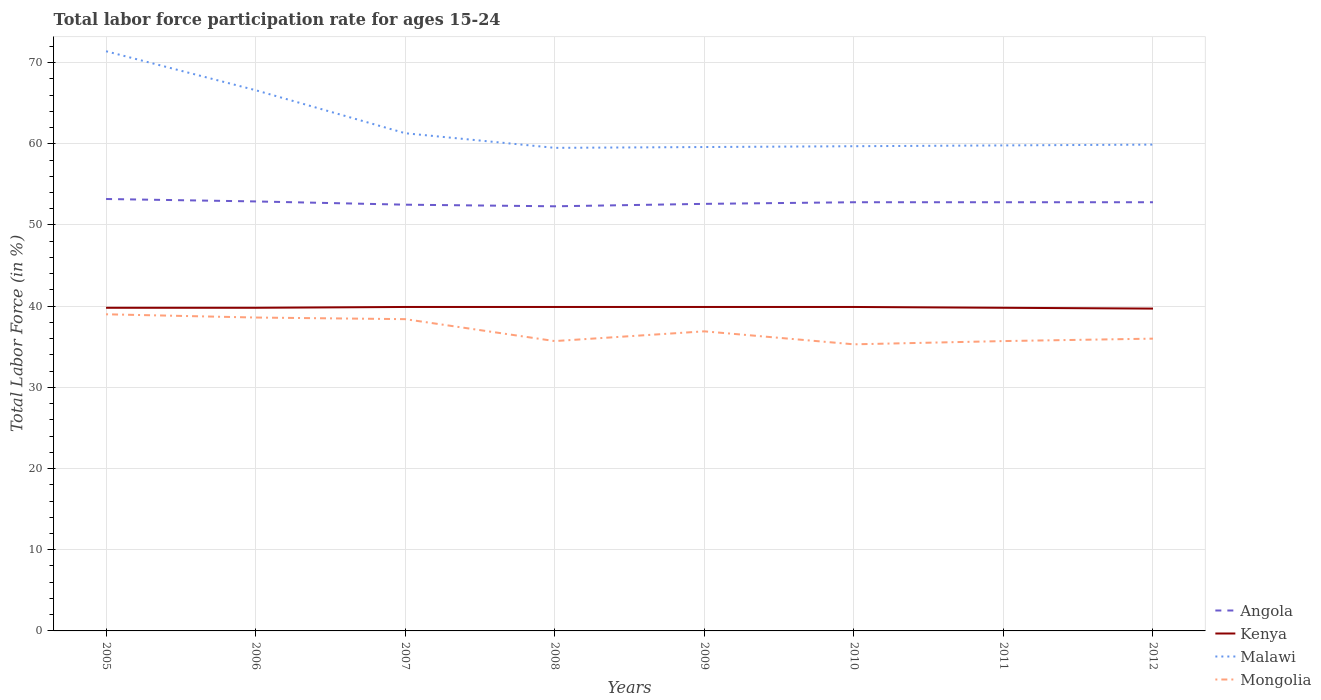Does the line corresponding to Mongolia intersect with the line corresponding to Angola?
Your answer should be compact. No. Across all years, what is the maximum labor force participation rate in Mongolia?
Make the answer very short. 35.3. In which year was the labor force participation rate in Mongolia maximum?
Offer a very short reply. 2010. What is the total labor force participation rate in Mongolia in the graph?
Keep it short and to the point. 0.4. What is the difference between the highest and the second highest labor force participation rate in Mongolia?
Give a very brief answer. 3.7. What is the difference between the highest and the lowest labor force participation rate in Malawi?
Your answer should be very brief. 2. Is the labor force participation rate in Kenya strictly greater than the labor force participation rate in Malawi over the years?
Your response must be concise. Yes. How many lines are there?
Provide a short and direct response. 4. How many years are there in the graph?
Provide a short and direct response. 8. Are the values on the major ticks of Y-axis written in scientific E-notation?
Provide a succinct answer. No. Does the graph contain any zero values?
Your response must be concise. No. How are the legend labels stacked?
Your answer should be very brief. Vertical. What is the title of the graph?
Offer a very short reply. Total labor force participation rate for ages 15-24. What is the label or title of the Y-axis?
Offer a very short reply. Total Labor Force (in %). What is the Total Labor Force (in %) of Angola in 2005?
Keep it short and to the point. 53.2. What is the Total Labor Force (in %) in Kenya in 2005?
Your answer should be compact. 39.8. What is the Total Labor Force (in %) of Malawi in 2005?
Your response must be concise. 71.4. What is the Total Labor Force (in %) of Angola in 2006?
Ensure brevity in your answer.  52.9. What is the Total Labor Force (in %) of Kenya in 2006?
Your answer should be very brief. 39.8. What is the Total Labor Force (in %) in Malawi in 2006?
Provide a succinct answer. 66.6. What is the Total Labor Force (in %) of Mongolia in 2006?
Ensure brevity in your answer.  38.6. What is the Total Labor Force (in %) in Angola in 2007?
Your response must be concise. 52.5. What is the Total Labor Force (in %) of Kenya in 2007?
Make the answer very short. 39.9. What is the Total Labor Force (in %) in Malawi in 2007?
Offer a very short reply. 61.3. What is the Total Labor Force (in %) in Mongolia in 2007?
Make the answer very short. 38.4. What is the Total Labor Force (in %) in Angola in 2008?
Your answer should be very brief. 52.3. What is the Total Labor Force (in %) in Kenya in 2008?
Your answer should be compact. 39.9. What is the Total Labor Force (in %) of Malawi in 2008?
Offer a very short reply. 59.5. What is the Total Labor Force (in %) of Mongolia in 2008?
Make the answer very short. 35.7. What is the Total Labor Force (in %) in Angola in 2009?
Provide a short and direct response. 52.6. What is the Total Labor Force (in %) of Kenya in 2009?
Give a very brief answer. 39.9. What is the Total Labor Force (in %) of Malawi in 2009?
Offer a very short reply. 59.6. What is the Total Labor Force (in %) in Mongolia in 2009?
Your response must be concise. 36.9. What is the Total Labor Force (in %) in Angola in 2010?
Offer a terse response. 52.8. What is the Total Labor Force (in %) of Kenya in 2010?
Offer a terse response. 39.9. What is the Total Labor Force (in %) of Malawi in 2010?
Provide a succinct answer. 59.7. What is the Total Labor Force (in %) of Mongolia in 2010?
Offer a very short reply. 35.3. What is the Total Labor Force (in %) in Angola in 2011?
Your answer should be very brief. 52.8. What is the Total Labor Force (in %) in Kenya in 2011?
Provide a short and direct response. 39.8. What is the Total Labor Force (in %) of Malawi in 2011?
Offer a very short reply. 59.8. What is the Total Labor Force (in %) in Mongolia in 2011?
Your answer should be very brief. 35.7. What is the Total Labor Force (in %) of Angola in 2012?
Provide a succinct answer. 52.8. What is the Total Labor Force (in %) in Kenya in 2012?
Give a very brief answer. 39.7. What is the Total Labor Force (in %) in Malawi in 2012?
Your response must be concise. 59.9. What is the Total Labor Force (in %) in Mongolia in 2012?
Offer a very short reply. 36. Across all years, what is the maximum Total Labor Force (in %) in Angola?
Offer a very short reply. 53.2. Across all years, what is the maximum Total Labor Force (in %) in Kenya?
Your answer should be compact. 39.9. Across all years, what is the maximum Total Labor Force (in %) of Malawi?
Offer a terse response. 71.4. Across all years, what is the minimum Total Labor Force (in %) of Angola?
Keep it short and to the point. 52.3. Across all years, what is the minimum Total Labor Force (in %) in Kenya?
Your answer should be compact. 39.7. Across all years, what is the minimum Total Labor Force (in %) in Malawi?
Give a very brief answer. 59.5. Across all years, what is the minimum Total Labor Force (in %) of Mongolia?
Your answer should be compact. 35.3. What is the total Total Labor Force (in %) in Angola in the graph?
Make the answer very short. 421.9. What is the total Total Labor Force (in %) of Kenya in the graph?
Keep it short and to the point. 318.7. What is the total Total Labor Force (in %) of Malawi in the graph?
Offer a terse response. 497.8. What is the total Total Labor Force (in %) of Mongolia in the graph?
Make the answer very short. 295.6. What is the difference between the Total Labor Force (in %) in Angola in 2005 and that in 2006?
Keep it short and to the point. 0.3. What is the difference between the Total Labor Force (in %) of Malawi in 2005 and that in 2007?
Your answer should be very brief. 10.1. What is the difference between the Total Labor Force (in %) in Angola in 2005 and that in 2008?
Give a very brief answer. 0.9. What is the difference between the Total Labor Force (in %) in Kenya in 2005 and that in 2008?
Give a very brief answer. -0.1. What is the difference between the Total Labor Force (in %) in Mongolia in 2005 and that in 2008?
Keep it short and to the point. 3.3. What is the difference between the Total Labor Force (in %) in Kenya in 2005 and that in 2009?
Ensure brevity in your answer.  -0.1. What is the difference between the Total Labor Force (in %) of Kenya in 2005 and that in 2010?
Keep it short and to the point. -0.1. What is the difference between the Total Labor Force (in %) in Mongolia in 2005 and that in 2010?
Keep it short and to the point. 3.7. What is the difference between the Total Labor Force (in %) in Angola in 2005 and that in 2011?
Offer a terse response. 0.4. What is the difference between the Total Labor Force (in %) in Kenya in 2005 and that in 2011?
Your answer should be very brief. 0. What is the difference between the Total Labor Force (in %) in Malawi in 2005 and that in 2011?
Give a very brief answer. 11.6. What is the difference between the Total Labor Force (in %) of Mongolia in 2005 and that in 2011?
Provide a succinct answer. 3.3. What is the difference between the Total Labor Force (in %) in Kenya in 2005 and that in 2012?
Your response must be concise. 0.1. What is the difference between the Total Labor Force (in %) in Malawi in 2005 and that in 2012?
Offer a very short reply. 11.5. What is the difference between the Total Labor Force (in %) in Malawi in 2006 and that in 2007?
Give a very brief answer. 5.3. What is the difference between the Total Labor Force (in %) in Mongolia in 2006 and that in 2009?
Make the answer very short. 1.7. What is the difference between the Total Labor Force (in %) of Angola in 2006 and that in 2011?
Give a very brief answer. 0.1. What is the difference between the Total Labor Force (in %) of Mongolia in 2006 and that in 2011?
Your answer should be compact. 2.9. What is the difference between the Total Labor Force (in %) of Malawi in 2006 and that in 2012?
Give a very brief answer. 6.7. What is the difference between the Total Labor Force (in %) in Mongolia in 2006 and that in 2012?
Offer a terse response. 2.6. What is the difference between the Total Labor Force (in %) in Kenya in 2007 and that in 2008?
Offer a very short reply. 0. What is the difference between the Total Labor Force (in %) in Kenya in 2007 and that in 2009?
Provide a short and direct response. 0. What is the difference between the Total Labor Force (in %) in Malawi in 2007 and that in 2009?
Your response must be concise. 1.7. What is the difference between the Total Labor Force (in %) of Angola in 2007 and that in 2010?
Provide a succinct answer. -0.3. What is the difference between the Total Labor Force (in %) of Malawi in 2007 and that in 2010?
Give a very brief answer. 1.6. What is the difference between the Total Labor Force (in %) in Mongolia in 2007 and that in 2010?
Your response must be concise. 3.1. What is the difference between the Total Labor Force (in %) in Kenya in 2007 and that in 2011?
Ensure brevity in your answer.  0.1. What is the difference between the Total Labor Force (in %) in Mongolia in 2007 and that in 2011?
Keep it short and to the point. 2.7. What is the difference between the Total Labor Force (in %) of Angola in 2007 and that in 2012?
Provide a succinct answer. -0.3. What is the difference between the Total Labor Force (in %) of Malawi in 2007 and that in 2012?
Provide a succinct answer. 1.4. What is the difference between the Total Labor Force (in %) in Mongolia in 2007 and that in 2012?
Make the answer very short. 2.4. What is the difference between the Total Labor Force (in %) of Angola in 2008 and that in 2010?
Offer a very short reply. -0.5. What is the difference between the Total Labor Force (in %) of Malawi in 2008 and that in 2010?
Make the answer very short. -0.2. What is the difference between the Total Labor Force (in %) in Kenya in 2008 and that in 2011?
Offer a very short reply. 0.1. What is the difference between the Total Labor Force (in %) of Mongolia in 2008 and that in 2011?
Your response must be concise. 0. What is the difference between the Total Labor Force (in %) of Angola in 2008 and that in 2012?
Provide a succinct answer. -0.5. What is the difference between the Total Labor Force (in %) in Kenya in 2008 and that in 2012?
Provide a succinct answer. 0.2. What is the difference between the Total Labor Force (in %) in Malawi in 2008 and that in 2012?
Provide a succinct answer. -0.4. What is the difference between the Total Labor Force (in %) of Kenya in 2009 and that in 2010?
Offer a terse response. 0. What is the difference between the Total Labor Force (in %) of Malawi in 2009 and that in 2010?
Make the answer very short. -0.1. What is the difference between the Total Labor Force (in %) of Mongolia in 2009 and that in 2010?
Offer a very short reply. 1.6. What is the difference between the Total Labor Force (in %) in Malawi in 2009 and that in 2011?
Make the answer very short. -0.2. What is the difference between the Total Labor Force (in %) in Mongolia in 2009 and that in 2011?
Your answer should be very brief. 1.2. What is the difference between the Total Labor Force (in %) in Mongolia in 2009 and that in 2012?
Provide a succinct answer. 0.9. What is the difference between the Total Labor Force (in %) in Angola in 2010 and that in 2011?
Offer a terse response. 0. What is the difference between the Total Labor Force (in %) in Kenya in 2010 and that in 2011?
Keep it short and to the point. 0.1. What is the difference between the Total Labor Force (in %) of Malawi in 2010 and that in 2011?
Provide a succinct answer. -0.1. What is the difference between the Total Labor Force (in %) in Mongolia in 2010 and that in 2011?
Provide a succinct answer. -0.4. What is the difference between the Total Labor Force (in %) of Angola in 2010 and that in 2012?
Provide a succinct answer. 0. What is the difference between the Total Labor Force (in %) of Kenya in 2010 and that in 2012?
Offer a very short reply. 0.2. What is the difference between the Total Labor Force (in %) of Malawi in 2010 and that in 2012?
Ensure brevity in your answer.  -0.2. What is the difference between the Total Labor Force (in %) in Mongolia in 2010 and that in 2012?
Provide a succinct answer. -0.7. What is the difference between the Total Labor Force (in %) in Malawi in 2011 and that in 2012?
Give a very brief answer. -0.1. What is the difference between the Total Labor Force (in %) of Mongolia in 2011 and that in 2012?
Give a very brief answer. -0.3. What is the difference between the Total Labor Force (in %) of Kenya in 2005 and the Total Labor Force (in %) of Malawi in 2006?
Ensure brevity in your answer.  -26.8. What is the difference between the Total Labor Force (in %) of Kenya in 2005 and the Total Labor Force (in %) of Mongolia in 2006?
Give a very brief answer. 1.2. What is the difference between the Total Labor Force (in %) of Malawi in 2005 and the Total Labor Force (in %) of Mongolia in 2006?
Your answer should be very brief. 32.8. What is the difference between the Total Labor Force (in %) in Angola in 2005 and the Total Labor Force (in %) in Malawi in 2007?
Give a very brief answer. -8.1. What is the difference between the Total Labor Force (in %) of Kenya in 2005 and the Total Labor Force (in %) of Malawi in 2007?
Offer a terse response. -21.5. What is the difference between the Total Labor Force (in %) in Angola in 2005 and the Total Labor Force (in %) in Kenya in 2008?
Offer a terse response. 13.3. What is the difference between the Total Labor Force (in %) of Angola in 2005 and the Total Labor Force (in %) of Malawi in 2008?
Keep it short and to the point. -6.3. What is the difference between the Total Labor Force (in %) of Kenya in 2005 and the Total Labor Force (in %) of Malawi in 2008?
Offer a terse response. -19.7. What is the difference between the Total Labor Force (in %) of Malawi in 2005 and the Total Labor Force (in %) of Mongolia in 2008?
Your response must be concise. 35.7. What is the difference between the Total Labor Force (in %) in Angola in 2005 and the Total Labor Force (in %) in Malawi in 2009?
Offer a very short reply. -6.4. What is the difference between the Total Labor Force (in %) of Angola in 2005 and the Total Labor Force (in %) of Mongolia in 2009?
Your response must be concise. 16.3. What is the difference between the Total Labor Force (in %) in Kenya in 2005 and the Total Labor Force (in %) in Malawi in 2009?
Keep it short and to the point. -19.8. What is the difference between the Total Labor Force (in %) in Kenya in 2005 and the Total Labor Force (in %) in Mongolia in 2009?
Ensure brevity in your answer.  2.9. What is the difference between the Total Labor Force (in %) of Malawi in 2005 and the Total Labor Force (in %) of Mongolia in 2009?
Give a very brief answer. 34.5. What is the difference between the Total Labor Force (in %) of Angola in 2005 and the Total Labor Force (in %) of Kenya in 2010?
Ensure brevity in your answer.  13.3. What is the difference between the Total Labor Force (in %) of Angola in 2005 and the Total Labor Force (in %) of Mongolia in 2010?
Make the answer very short. 17.9. What is the difference between the Total Labor Force (in %) in Kenya in 2005 and the Total Labor Force (in %) in Malawi in 2010?
Your response must be concise. -19.9. What is the difference between the Total Labor Force (in %) in Kenya in 2005 and the Total Labor Force (in %) in Mongolia in 2010?
Offer a very short reply. 4.5. What is the difference between the Total Labor Force (in %) in Malawi in 2005 and the Total Labor Force (in %) in Mongolia in 2010?
Provide a succinct answer. 36.1. What is the difference between the Total Labor Force (in %) of Angola in 2005 and the Total Labor Force (in %) of Kenya in 2011?
Your answer should be very brief. 13.4. What is the difference between the Total Labor Force (in %) of Angola in 2005 and the Total Labor Force (in %) of Malawi in 2011?
Offer a terse response. -6.6. What is the difference between the Total Labor Force (in %) in Kenya in 2005 and the Total Labor Force (in %) in Malawi in 2011?
Provide a short and direct response. -20. What is the difference between the Total Labor Force (in %) in Malawi in 2005 and the Total Labor Force (in %) in Mongolia in 2011?
Provide a short and direct response. 35.7. What is the difference between the Total Labor Force (in %) in Angola in 2005 and the Total Labor Force (in %) in Kenya in 2012?
Keep it short and to the point. 13.5. What is the difference between the Total Labor Force (in %) of Angola in 2005 and the Total Labor Force (in %) of Malawi in 2012?
Keep it short and to the point. -6.7. What is the difference between the Total Labor Force (in %) in Kenya in 2005 and the Total Labor Force (in %) in Malawi in 2012?
Your answer should be compact. -20.1. What is the difference between the Total Labor Force (in %) in Kenya in 2005 and the Total Labor Force (in %) in Mongolia in 2012?
Keep it short and to the point. 3.8. What is the difference between the Total Labor Force (in %) of Malawi in 2005 and the Total Labor Force (in %) of Mongolia in 2012?
Your answer should be very brief. 35.4. What is the difference between the Total Labor Force (in %) in Kenya in 2006 and the Total Labor Force (in %) in Malawi in 2007?
Offer a very short reply. -21.5. What is the difference between the Total Labor Force (in %) of Kenya in 2006 and the Total Labor Force (in %) of Mongolia in 2007?
Offer a terse response. 1.4. What is the difference between the Total Labor Force (in %) in Malawi in 2006 and the Total Labor Force (in %) in Mongolia in 2007?
Your answer should be very brief. 28.2. What is the difference between the Total Labor Force (in %) of Angola in 2006 and the Total Labor Force (in %) of Malawi in 2008?
Offer a very short reply. -6.6. What is the difference between the Total Labor Force (in %) of Angola in 2006 and the Total Labor Force (in %) of Mongolia in 2008?
Your answer should be compact. 17.2. What is the difference between the Total Labor Force (in %) in Kenya in 2006 and the Total Labor Force (in %) in Malawi in 2008?
Make the answer very short. -19.7. What is the difference between the Total Labor Force (in %) of Malawi in 2006 and the Total Labor Force (in %) of Mongolia in 2008?
Ensure brevity in your answer.  30.9. What is the difference between the Total Labor Force (in %) in Angola in 2006 and the Total Labor Force (in %) in Kenya in 2009?
Your response must be concise. 13. What is the difference between the Total Labor Force (in %) of Kenya in 2006 and the Total Labor Force (in %) of Malawi in 2009?
Your answer should be compact. -19.8. What is the difference between the Total Labor Force (in %) of Malawi in 2006 and the Total Labor Force (in %) of Mongolia in 2009?
Offer a very short reply. 29.7. What is the difference between the Total Labor Force (in %) of Angola in 2006 and the Total Labor Force (in %) of Kenya in 2010?
Your answer should be compact. 13. What is the difference between the Total Labor Force (in %) of Angola in 2006 and the Total Labor Force (in %) of Malawi in 2010?
Give a very brief answer. -6.8. What is the difference between the Total Labor Force (in %) in Kenya in 2006 and the Total Labor Force (in %) in Malawi in 2010?
Make the answer very short. -19.9. What is the difference between the Total Labor Force (in %) in Kenya in 2006 and the Total Labor Force (in %) in Mongolia in 2010?
Give a very brief answer. 4.5. What is the difference between the Total Labor Force (in %) of Malawi in 2006 and the Total Labor Force (in %) of Mongolia in 2010?
Offer a very short reply. 31.3. What is the difference between the Total Labor Force (in %) in Angola in 2006 and the Total Labor Force (in %) in Kenya in 2011?
Your answer should be compact. 13.1. What is the difference between the Total Labor Force (in %) in Angola in 2006 and the Total Labor Force (in %) in Malawi in 2011?
Give a very brief answer. -6.9. What is the difference between the Total Labor Force (in %) in Angola in 2006 and the Total Labor Force (in %) in Mongolia in 2011?
Ensure brevity in your answer.  17.2. What is the difference between the Total Labor Force (in %) in Malawi in 2006 and the Total Labor Force (in %) in Mongolia in 2011?
Give a very brief answer. 30.9. What is the difference between the Total Labor Force (in %) in Kenya in 2006 and the Total Labor Force (in %) in Malawi in 2012?
Provide a short and direct response. -20.1. What is the difference between the Total Labor Force (in %) in Kenya in 2006 and the Total Labor Force (in %) in Mongolia in 2012?
Keep it short and to the point. 3.8. What is the difference between the Total Labor Force (in %) of Malawi in 2006 and the Total Labor Force (in %) of Mongolia in 2012?
Give a very brief answer. 30.6. What is the difference between the Total Labor Force (in %) in Angola in 2007 and the Total Labor Force (in %) in Malawi in 2008?
Make the answer very short. -7. What is the difference between the Total Labor Force (in %) of Kenya in 2007 and the Total Labor Force (in %) of Malawi in 2008?
Offer a very short reply. -19.6. What is the difference between the Total Labor Force (in %) in Malawi in 2007 and the Total Labor Force (in %) in Mongolia in 2008?
Offer a terse response. 25.6. What is the difference between the Total Labor Force (in %) of Angola in 2007 and the Total Labor Force (in %) of Malawi in 2009?
Offer a terse response. -7.1. What is the difference between the Total Labor Force (in %) of Angola in 2007 and the Total Labor Force (in %) of Mongolia in 2009?
Offer a terse response. 15.6. What is the difference between the Total Labor Force (in %) in Kenya in 2007 and the Total Labor Force (in %) in Malawi in 2009?
Offer a very short reply. -19.7. What is the difference between the Total Labor Force (in %) in Malawi in 2007 and the Total Labor Force (in %) in Mongolia in 2009?
Offer a very short reply. 24.4. What is the difference between the Total Labor Force (in %) of Angola in 2007 and the Total Labor Force (in %) of Kenya in 2010?
Give a very brief answer. 12.6. What is the difference between the Total Labor Force (in %) in Angola in 2007 and the Total Labor Force (in %) in Mongolia in 2010?
Offer a very short reply. 17.2. What is the difference between the Total Labor Force (in %) of Kenya in 2007 and the Total Labor Force (in %) of Malawi in 2010?
Give a very brief answer. -19.8. What is the difference between the Total Labor Force (in %) in Kenya in 2007 and the Total Labor Force (in %) in Mongolia in 2010?
Your answer should be very brief. 4.6. What is the difference between the Total Labor Force (in %) in Angola in 2007 and the Total Labor Force (in %) in Kenya in 2011?
Offer a very short reply. 12.7. What is the difference between the Total Labor Force (in %) of Angola in 2007 and the Total Labor Force (in %) of Malawi in 2011?
Your answer should be compact. -7.3. What is the difference between the Total Labor Force (in %) of Kenya in 2007 and the Total Labor Force (in %) of Malawi in 2011?
Your answer should be very brief. -19.9. What is the difference between the Total Labor Force (in %) in Kenya in 2007 and the Total Labor Force (in %) in Mongolia in 2011?
Your response must be concise. 4.2. What is the difference between the Total Labor Force (in %) in Malawi in 2007 and the Total Labor Force (in %) in Mongolia in 2011?
Give a very brief answer. 25.6. What is the difference between the Total Labor Force (in %) in Angola in 2007 and the Total Labor Force (in %) in Malawi in 2012?
Your response must be concise. -7.4. What is the difference between the Total Labor Force (in %) of Angola in 2007 and the Total Labor Force (in %) of Mongolia in 2012?
Provide a short and direct response. 16.5. What is the difference between the Total Labor Force (in %) of Kenya in 2007 and the Total Labor Force (in %) of Malawi in 2012?
Ensure brevity in your answer.  -20. What is the difference between the Total Labor Force (in %) in Kenya in 2007 and the Total Labor Force (in %) in Mongolia in 2012?
Ensure brevity in your answer.  3.9. What is the difference between the Total Labor Force (in %) in Malawi in 2007 and the Total Labor Force (in %) in Mongolia in 2012?
Offer a very short reply. 25.3. What is the difference between the Total Labor Force (in %) in Kenya in 2008 and the Total Labor Force (in %) in Malawi in 2009?
Give a very brief answer. -19.7. What is the difference between the Total Labor Force (in %) of Malawi in 2008 and the Total Labor Force (in %) of Mongolia in 2009?
Keep it short and to the point. 22.6. What is the difference between the Total Labor Force (in %) in Angola in 2008 and the Total Labor Force (in %) in Mongolia in 2010?
Provide a short and direct response. 17. What is the difference between the Total Labor Force (in %) of Kenya in 2008 and the Total Labor Force (in %) of Malawi in 2010?
Make the answer very short. -19.8. What is the difference between the Total Labor Force (in %) in Kenya in 2008 and the Total Labor Force (in %) in Mongolia in 2010?
Your answer should be compact. 4.6. What is the difference between the Total Labor Force (in %) of Malawi in 2008 and the Total Labor Force (in %) of Mongolia in 2010?
Provide a succinct answer. 24.2. What is the difference between the Total Labor Force (in %) in Angola in 2008 and the Total Labor Force (in %) in Kenya in 2011?
Ensure brevity in your answer.  12.5. What is the difference between the Total Labor Force (in %) in Kenya in 2008 and the Total Labor Force (in %) in Malawi in 2011?
Give a very brief answer. -19.9. What is the difference between the Total Labor Force (in %) in Malawi in 2008 and the Total Labor Force (in %) in Mongolia in 2011?
Provide a succinct answer. 23.8. What is the difference between the Total Labor Force (in %) of Angola in 2008 and the Total Labor Force (in %) of Kenya in 2012?
Offer a terse response. 12.6. What is the difference between the Total Labor Force (in %) of Angola in 2008 and the Total Labor Force (in %) of Mongolia in 2012?
Your answer should be very brief. 16.3. What is the difference between the Total Labor Force (in %) of Kenya in 2008 and the Total Labor Force (in %) of Malawi in 2012?
Give a very brief answer. -20. What is the difference between the Total Labor Force (in %) in Malawi in 2008 and the Total Labor Force (in %) in Mongolia in 2012?
Provide a succinct answer. 23.5. What is the difference between the Total Labor Force (in %) of Kenya in 2009 and the Total Labor Force (in %) of Malawi in 2010?
Provide a succinct answer. -19.8. What is the difference between the Total Labor Force (in %) in Malawi in 2009 and the Total Labor Force (in %) in Mongolia in 2010?
Your answer should be very brief. 24.3. What is the difference between the Total Labor Force (in %) in Angola in 2009 and the Total Labor Force (in %) in Kenya in 2011?
Provide a short and direct response. 12.8. What is the difference between the Total Labor Force (in %) in Angola in 2009 and the Total Labor Force (in %) in Malawi in 2011?
Provide a succinct answer. -7.2. What is the difference between the Total Labor Force (in %) in Angola in 2009 and the Total Labor Force (in %) in Mongolia in 2011?
Offer a terse response. 16.9. What is the difference between the Total Labor Force (in %) of Kenya in 2009 and the Total Labor Force (in %) of Malawi in 2011?
Your answer should be compact. -19.9. What is the difference between the Total Labor Force (in %) of Kenya in 2009 and the Total Labor Force (in %) of Mongolia in 2011?
Your answer should be compact. 4.2. What is the difference between the Total Labor Force (in %) of Malawi in 2009 and the Total Labor Force (in %) of Mongolia in 2011?
Your answer should be very brief. 23.9. What is the difference between the Total Labor Force (in %) of Kenya in 2009 and the Total Labor Force (in %) of Malawi in 2012?
Your answer should be compact. -20. What is the difference between the Total Labor Force (in %) in Kenya in 2009 and the Total Labor Force (in %) in Mongolia in 2012?
Offer a terse response. 3.9. What is the difference between the Total Labor Force (in %) of Malawi in 2009 and the Total Labor Force (in %) of Mongolia in 2012?
Ensure brevity in your answer.  23.6. What is the difference between the Total Labor Force (in %) of Kenya in 2010 and the Total Labor Force (in %) of Malawi in 2011?
Your answer should be very brief. -19.9. What is the difference between the Total Labor Force (in %) of Angola in 2010 and the Total Labor Force (in %) of Kenya in 2012?
Ensure brevity in your answer.  13.1. What is the difference between the Total Labor Force (in %) of Angola in 2010 and the Total Labor Force (in %) of Mongolia in 2012?
Give a very brief answer. 16.8. What is the difference between the Total Labor Force (in %) of Kenya in 2010 and the Total Labor Force (in %) of Malawi in 2012?
Your answer should be very brief. -20. What is the difference between the Total Labor Force (in %) in Malawi in 2010 and the Total Labor Force (in %) in Mongolia in 2012?
Give a very brief answer. 23.7. What is the difference between the Total Labor Force (in %) in Angola in 2011 and the Total Labor Force (in %) in Malawi in 2012?
Make the answer very short. -7.1. What is the difference between the Total Labor Force (in %) of Angola in 2011 and the Total Labor Force (in %) of Mongolia in 2012?
Provide a short and direct response. 16.8. What is the difference between the Total Labor Force (in %) in Kenya in 2011 and the Total Labor Force (in %) in Malawi in 2012?
Keep it short and to the point. -20.1. What is the difference between the Total Labor Force (in %) in Malawi in 2011 and the Total Labor Force (in %) in Mongolia in 2012?
Offer a very short reply. 23.8. What is the average Total Labor Force (in %) of Angola per year?
Ensure brevity in your answer.  52.74. What is the average Total Labor Force (in %) in Kenya per year?
Provide a succinct answer. 39.84. What is the average Total Labor Force (in %) in Malawi per year?
Offer a very short reply. 62.23. What is the average Total Labor Force (in %) of Mongolia per year?
Ensure brevity in your answer.  36.95. In the year 2005, what is the difference between the Total Labor Force (in %) in Angola and Total Labor Force (in %) in Malawi?
Offer a terse response. -18.2. In the year 2005, what is the difference between the Total Labor Force (in %) in Angola and Total Labor Force (in %) in Mongolia?
Give a very brief answer. 14.2. In the year 2005, what is the difference between the Total Labor Force (in %) in Kenya and Total Labor Force (in %) in Malawi?
Keep it short and to the point. -31.6. In the year 2005, what is the difference between the Total Labor Force (in %) in Malawi and Total Labor Force (in %) in Mongolia?
Keep it short and to the point. 32.4. In the year 2006, what is the difference between the Total Labor Force (in %) of Angola and Total Labor Force (in %) of Kenya?
Your answer should be compact. 13.1. In the year 2006, what is the difference between the Total Labor Force (in %) in Angola and Total Labor Force (in %) in Malawi?
Your response must be concise. -13.7. In the year 2006, what is the difference between the Total Labor Force (in %) of Kenya and Total Labor Force (in %) of Malawi?
Offer a terse response. -26.8. In the year 2006, what is the difference between the Total Labor Force (in %) in Malawi and Total Labor Force (in %) in Mongolia?
Give a very brief answer. 28. In the year 2007, what is the difference between the Total Labor Force (in %) of Kenya and Total Labor Force (in %) of Malawi?
Ensure brevity in your answer.  -21.4. In the year 2007, what is the difference between the Total Labor Force (in %) in Malawi and Total Labor Force (in %) in Mongolia?
Keep it short and to the point. 22.9. In the year 2008, what is the difference between the Total Labor Force (in %) in Angola and Total Labor Force (in %) in Malawi?
Give a very brief answer. -7.2. In the year 2008, what is the difference between the Total Labor Force (in %) in Kenya and Total Labor Force (in %) in Malawi?
Give a very brief answer. -19.6. In the year 2008, what is the difference between the Total Labor Force (in %) of Kenya and Total Labor Force (in %) of Mongolia?
Keep it short and to the point. 4.2. In the year 2008, what is the difference between the Total Labor Force (in %) in Malawi and Total Labor Force (in %) in Mongolia?
Offer a very short reply. 23.8. In the year 2009, what is the difference between the Total Labor Force (in %) in Angola and Total Labor Force (in %) in Kenya?
Offer a very short reply. 12.7. In the year 2009, what is the difference between the Total Labor Force (in %) in Angola and Total Labor Force (in %) in Malawi?
Make the answer very short. -7. In the year 2009, what is the difference between the Total Labor Force (in %) in Angola and Total Labor Force (in %) in Mongolia?
Provide a short and direct response. 15.7. In the year 2009, what is the difference between the Total Labor Force (in %) in Kenya and Total Labor Force (in %) in Malawi?
Offer a very short reply. -19.7. In the year 2009, what is the difference between the Total Labor Force (in %) in Malawi and Total Labor Force (in %) in Mongolia?
Make the answer very short. 22.7. In the year 2010, what is the difference between the Total Labor Force (in %) in Angola and Total Labor Force (in %) in Malawi?
Your answer should be very brief. -6.9. In the year 2010, what is the difference between the Total Labor Force (in %) in Kenya and Total Labor Force (in %) in Malawi?
Provide a short and direct response. -19.8. In the year 2010, what is the difference between the Total Labor Force (in %) in Kenya and Total Labor Force (in %) in Mongolia?
Give a very brief answer. 4.6. In the year 2010, what is the difference between the Total Labor Force (in %) of Malawi and Total Labor Force (in %) of Mongolia?
Make the answer very short. 24.4. In the year 2011, what is the difference between the Total Labor Force (in %) in Angola and Total Labor Force (in %) in Mongolia?
Your answer should be very brief. 17.1. In the year 2011, what is the difference between the Total Labor Force (in %) of Kenya and Total Labor Force (in %) of Mongolia?
Offer a very short reply. 4.1. In the year 2011, what is the difference between the Total Labor Force (in %) of Malawi and Total Labor Force (in %) of Mongolia?
Your response must be concise. 24.1. In the year 2012, what is the difference between the Total Labor Force (in %) in Angola and Total Labor Force (in %) in Kenya?
Provide a short and direct response. 13.1. In the year 2012, what is the difference between the Total Labor Force (in %) of Angola and Total Labor Force (in %) of Malawi?
Give a very brief answer. -7.1. In the year 2012, what is the difference between the Total Labor Force (in %) in Angola and Total Labor Force (in %) in Mongolia?
Your answer should be very brief. 16.8. In the year 2012, what is the difference between the Total Labor Force (in %) in Kenya and Total Labor Force (in %) in Malawi?
Your answer should be very brief. -20.2. In the year 2012, what is the difference between the Total Labor Force (in %) in Malawi and Total Labor Force (in %) in Mongolia?
Provide a short and direct response. 23.9. What is the ratio of the Total Labor Force (in %) in Kenya in 2005 to that in 2006?
Provide a succinct answer. 1. What is the ratio of the Total Labor Force (in %) in Malawi in 2005 to that in 2006?
Offer a terse response. 1.07. What is the ratio of the Total Labor Force (in %) of Mongolia in 2005 to that in 2006?
Ensure brevity in your answer.  1.01. What is the ratio of the Total Labor Force (in %) of Angola in 2005 to that in 2007?
Make the answer very short. 1.01. What is the ratio of the Total Labor Force (in %) in Kenya in 2005 to that in 2007?
Offer a terse response. 1. What is the ratio of the Total Labor Force (in %) in Malawi in 2005 to that in 2007?
Provide a short and direct response. 1.16. What is the ratio of the Total Labor Force (in %) of Mongolia in 2005 to that in 2007?
Give a very brief answer. 1.02. What is the ratio of the Total Labor Force (in %) of Angola in 2005 to that in 2008?
Give a very brief answer. 1.02. What is the ratio of the Total Labor Force (in %) of Mongolia in 2005 to that in 2008?
Ensure brevity in your answer.  1.09. What is the ratio of the Total Labor Force (in %) of Angola in 2005 to that in 2009?
Your answer should be very brief. 1.01. What is the ratio of the Total Labor Force (in %) in Malawi in 2005 to that in 2009?
Provide a succinct answer. 1.2. What is the ratio of the Total Labor Force (in %) of Mongolia in 2005 to that in 2009?
Your answer should be very brief. 1.06. What is the ratio of the Total Labor Force (in %) in Angola in 2005 to that in 2010?
Keep it short and to the point. 1.01. What is the ratio of the Total Labor Force (in %) of Malawi in 2005 to that in 2010?
Your answer should be very brief. 1.2. What is the ratio of the Total Labor Force (in %) of Mongolia in 2005 to that in 2010?
Keep it short and to the point. 1.1. What is the ratio of the Total Labor Force (in %) in Angola in 2005 to that in 2011?
Ensure brevity in your answer.  1.01. What is the ratio of the Total Labor Force (in %) in Kenya in 2005 to that in 2011?
Your answer should be very brief. 1. What is the ratio of the Total Labor Force (in %) of Malawi in 2005 to that in 2011?
Your response must be concise. 1.19. What is the ratio of the Total Labor Force (in %) of Mongolia in 2005 to that in 2011?
Provide a short and direct response. 1.09. What is the ratio of the Total Labor Force (in %) of Angola in 2005 to that in 2012?
Your response must be concise. 1.01. What is the ratio of the Total Labor Force (in %) in Malawi in 2005 to that in 2012?
Give a very brief answer. 1.19. What is the ratio of the Total Labor Force (in %) of Angola in 2006 to that in 2007?
Provide a short and direct response. 1.01. What is the ratio of the Total Labor Force (in %) in Kenya in 2006 to that in 2007?
Your answer should be compact. 1. What is the ratio of the Total Labor Force (in %) in Malawi in 2006 to that in 2007?
Your response must be concise. 1.09. What is the ratio of the Total Labor Force (in %) in Mongolia in 2006 to that in 2007?
Offer a terse response. 1.01. What is the ratio of the Total Labor Force (in %) in Angola in 2006 to that in 2008?
Keep it short and to the point. 1.01. What is the ratio of the Total Labor Force (in %) of Kenya in 2006 to that in 2008?
Offer a terse response. 1. What is the ratio of the Total Labor Force (in %) of Malawi in 2006 to that in 2008?
Your answer should be compact. 1.12. What is the ratio of the Total Labor Force (in %) of Mongolia in 2006 to that in 2008?
Make the answer very short. 1.08. What is the ratio of the Total Labor Force (in %) of Kenya in 2006 to that in 2009?
Offer a very short reply. 1. What is the ratio of the Total Labor Force (in %) of Malawi in 2006 to that in 2009?
Your response must be concise. 1.12. What is the ratio of the Total Labor Force (in %) of Mongolia in 2006 to that in 2009?
Offer a terse response. 1.05. What is the ratio of the Total Labor Force (in %) in Angola in 2006 to that in 2010?
Provide a succinct answer. 1. What is the ratio of the Total Labor Force (in %) of Malawi in 2006 to that in 2010?
Ensure brevity in your answer.  1.12. What is the ratio of the Total Labor Force (in %) of Mongolia in 2006 to that in 2010?
Your answer should be very brief. 1.09. What is the ratio of the Total Labor Force (in %) of Angola in 2006 to that in 2011?
Offer a terse response. 1. What is the ratio of the Total Labor Force (in %) of Malawi in 2006 to that in 2011?
Your response must be concise. 1.11. What is the ratio of the Total Labor Force (in %) in Mongolia in 2006 to that in 2011?
Provide a short and direct response. 1.08. What is the ratio of the Total Labor Force (in %) of Kenya in 2006 to that in 2012?
Offer a very short reply. 1. What is the ratio of the Total Labor Force (in %) of Malawi in 2006 to that in 2012?
Your response must be concise. 1.11. What is the ratio of the Total Labor Force (in %) of Mongolia in 2006 to that in 2012?
Your response must be concise. 1.07. What is the ratio of the Total Labor Force (in %) of Angola in 2007 to that in 2008?
Your answer should be very brief. 1. What is the ratio of the Total Labor Force (in %) in Malawi in 2007 to that in 2008?
Offer a very short reply. 1.03. What is the ratio of the Total Labor Force (in %) in Mongolia in 2007 to that in 2008?
Provide a short and direct response. 1.08. What is the ratio of the Total Labor Force (in %) in Angola in 2007 to that in 2009?
Offer a very short reply. 1. What is the ratio of the Total Labor Force (in %) of Malawi in 2007 to that in 2009?
Keep it short and to the point. 1.03. What is the ratio of the Total Labor Force (in %) in Mongolia in 2007 to that in 2009?
Your response must be concise. 1.04. What is the ratio of the Total Labor Force (in %) of Malawi in 2007 to that in 2010?
Ensure brevity in your answer.  1.03. What is the ratio of the Total Labor Force (in %) of Mongolia in 2007 to that in 2010?
Offer a very short reply. 1.09. What is the ratio of the Total Labor Force (in %) in Kenya in 2007 to that in 2011?
Offer a terse response. 1. What is the ratio of the Total Labor Force (in %) of Malawi in 2007 to that in 2011?
Keep it short and to the point. 1.03. What is the ratio of the Total Labor Force (in %) in Mongolia in 2007 to that in 2011?
Offer a terse response. 1.08. What is the ratio of the Total Labor Force (in %) in Malawi in 2007 to that in 2012?
Your answer should be very brief. 1.02. What is the ratio of the Total Labor Force (in %) in Mongolia in 2007 to that in 2012?
Keep it short and to the point. 1.07. What is the ratio of the Total Labor Force (in %) of Angola in 2008 to that in 2009?
Offer a very short reply. 0.99. What is the ratio of the Total Labor Force (in %) of Kenya in 2008 to that in 2009?
Provide a succinct answer. 1. What is the ratio of the Total Labor Force (in %) in Malawi in 2008 to that in 2009?
Offer a terse response. 1. What is the ratio of the Total Labor Force (in %) in Mongolia in 2008 to that in 2009?
Keep it short and to the point. 0.97. What is the ratio of the Total Labor Force (in %) in Kenya in 2008 to that in 2010?
Keep it short and to the point. 1. What is the ratio of the Total Labor Force (in %) of Malawi in 2008 to that in 2010?
Your response must be concise. 1. What is the ratio of the Total Labor Force (in %) in Mongolia in 2008 to that in 2010?
Your answer should be compact. 1.01. What is the ratio of the Total Labor Force (in %) of Kenya in 2008 to that in 2011?
Offer a terse response. 1. What is the ratio of the Total Labor Force (in %) in Malawi in 2008 to that in 2011?
Give a very brief answer. 0.99. What is the ratio of the Total Labor Force (in %) of Angola in 2008 to that in 2012?
Offer a terse response. 0.99. What is the ratio of the Total Labor Force (in %) in Malawi in 2008 to that in 2012?
Give a very brief answer. 0.99. What is the ratio of the Total Labor Force (in %) in Mongolia in 2008 to that in 2012?
Offer a terse response. 0.99. What is the ratio of the Total Labor Force (in %) in Angola in 2009 to that in 2010?
Give a very brief answer. 1. What is the ratio of the Total Labor Force (in %) of Mongolia in 2009 to that in 2010?
Provide a short and direct response. 1.05. What is the ratio of the Total Labor Force (in %) in Kenya in 2009 to that in 2011?
Make the answer very short. 1. What is the ratio of the Total Labor Force (in %) in Mongolia in 2009 to that in 2011?
Give a very brief answer. 1.03. What is the ratio of the Total Labor Force (in %) of Kenya in 2009 to that in 2012?
Provide a short and direct response. 1. What is the ratio of the Total Labor Force (in %) of Malawi in 2009 to that in 2012?
Offer a very short reply. 0.99. What is the ratio of the Total Labor Force (in %) in Mongolia in 2009 to that in 2012?
Ensure brevity in your answer.  1.02. What is the ratio of the Total Labor Force (in %) of Mongolia in 2010 to that in 2011?
Offer a very short reply. 0.99. What is the ratio of the Total Labor Force (in %) of Kenya in 2010 to that in 2012?
Your answer should be very brief. 1. What is the ratio of the Total Labor Force (in %) of Malawi in 2010 to that in 2012?
Give a very brief answer. 1. What is the ratio of the Total Labor Force (in %) in Mongolia in 2010 to that in 2012?
Make the answer very short. 0.98. What is the ratio of the Total Labor Force (in %) of Kenya in 2011 to that in 2012?
Ensure brevity in your answer.  1. What is the ratio of the Total Labor Force (in %) in Malawi in 2011 to that in 2012?
Your answer should be compact. 1. What is the ratio of the Total Labor Force (in %) of Mongolia in 2011 to that in 2012?
Give a very brief answer. 0.99. What is the difference between the highest and the second highest Total Labor Force (in %) of Kenya?
Offer a very short reply. 0. What is the difference between the highest and the lowest Total Labor Force (in %) in Angola?
Offer a terse response. 0.9. What is the difference between the highest and the lowest Total Labor Force (in %) of Malawi?
Offer a terse response. 11.9. 